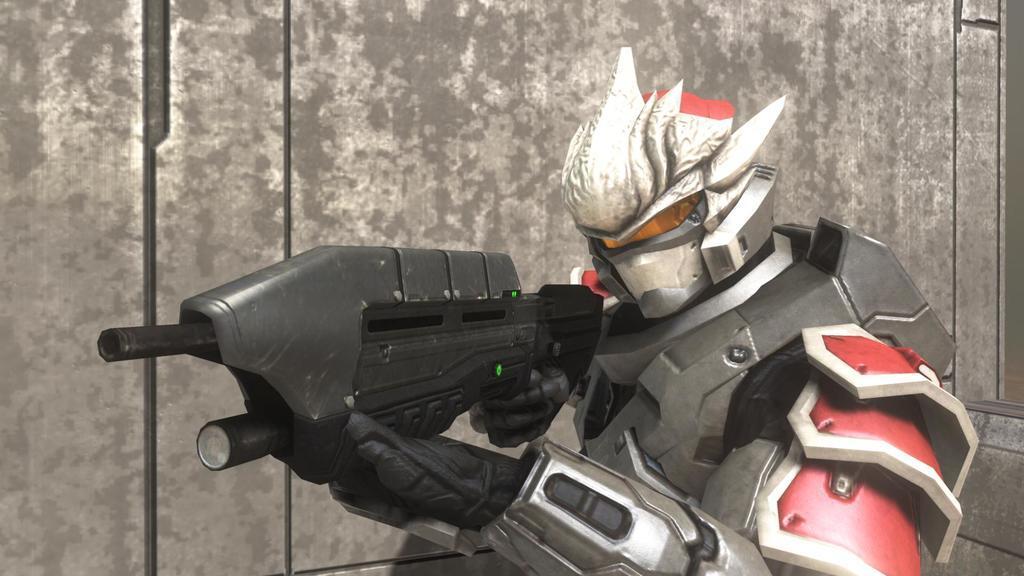Describe this image in one or two sentences. In the picture I can see an animated character who is holding a gun in hands. In the background I can see a wall. 